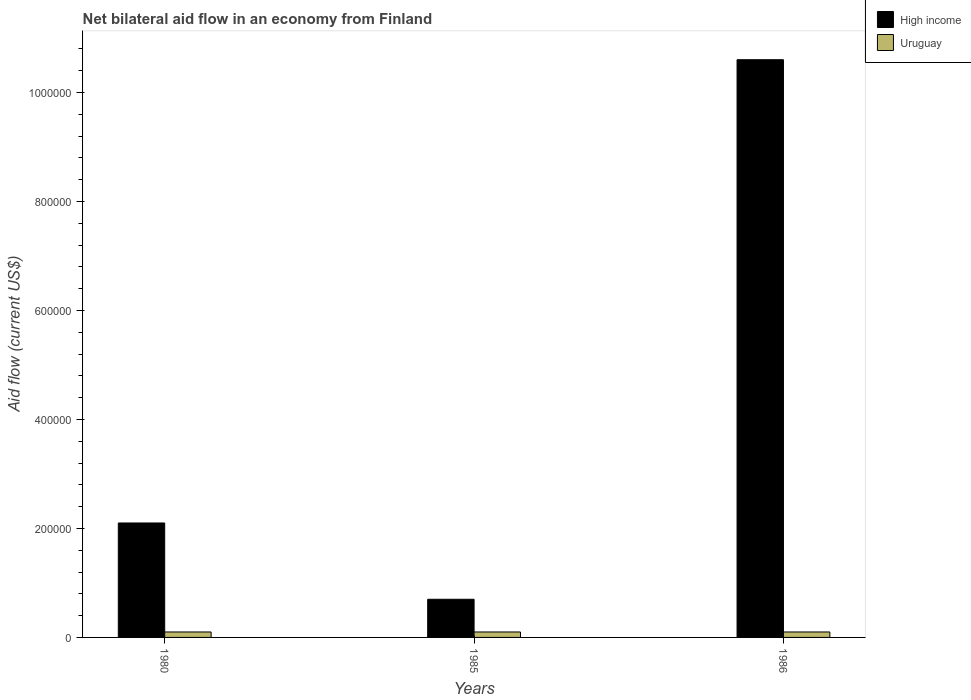How many different coloured bars are there?
Provide a succinct answer. 2. How many groups of bars are there?
Provide a succinct answer. 3. Are the number of bars per tick equal to the number of legend labels?
Make the answer very short. Yes. How many bars are there on the 3rd tick from the right?
Give a very brief answer. 2. What is the label of the 2nd group of bars from the left?
Your answer should be very brief. 1985. In how many cases, is the number of bars for a given year not equal to the number of legend labels?
Your answer should be compact. 0. Across all years, what is the maximum net bilateral aid flow in High income?
Make the answer very short. 1.06e+06. In which year was the net bilateral aid flow in High income maximum?
Give a very brief answer. 1986. In which year was the net bilateral aid flow in Uruguay minimum?
Your answer should be compact. 1980. What is the difference between the net bilateral aid flow in High income in 1980 and that in 1986?
Offer a very short reply. -8.50e+05. What is the difference between the net bilateral aid flow in High income in 1985 and the net bilateral aid flow in Uruguay in 1980?
Ensure brevity in your answer.  6.00e+04. What is the average net bilateral aid flow in High income per year?
Keep it short and to the point. 4.47e+05. In the year 1980, what is the difference between the net bilateral aid flow in Uruguay and net bilateral aid flow in High income?
Make the answer very short. -2.00e+05. Is the net bilateral aid flow in High income in 1980 less than that in 1985?
Your response must be concise. No. Is the difference between the net bilateral aid flow in Uruguay in 1985 and 1986 greater than the difference between the net bilateral aid flow in High income in 1985 and 1986?
Give a very brief answer. Yes. What is the difference between the highest and the second highest net bilateral aid flow in Uruguay?
Offer a terse response. 0. What is the difference between the highest and the lowest net bilateral aid flow in High income?
Provide a short and direct response. 9.90e+05. In how many years, is the net bilateral aid flow in High income greater than the average net bilateral aid flow in High income taken over all years?
Your response must be concise. 1. Is the sum of the net bilateral aid flow in Uruguay in 1980 and 1985 greater than the maximum net bilateral aid flow in High income across all years?
Your answer should be compact. No. What does the 2nd bar from the left in 1986 represents?
Keep it short and to the point. Uruguay. What does the 1st bar from the right in 1986 represents?
Keep it short and to the point. Uruguay. Are all the bars in the graph horizontal?
Give a very brief answer. No. Are the values on the major ticks of Y-axis written in scientific E-notation?
Your answer should be very brief. No. How many legend labels are there?
Offer a terse response. 2. How are the legend labels stacked?
Make the answer very short. Vertical. What is the title of the graph?
Make the answer very short. Net bilateral aid flow in an economy from Finland. What is the label or title of the Y-axis?
Keep it short and to the point. Aid flow (current US$). What is the Aid flow (current US$) of High income in 1980?
Make the answer very short. 2.10e+05. What is the Aid flow (current US$) of High income in 1985?
Your response must be concise. 7.00e+04. What is the Aid flow (current US$) in High income in 1986?
Offer a very short reply. 1.06e+06. What is the Aid flow (current US$) in Uruguay in 1986?
Offer a very short reply. 10000. Across all years, what is the maximum Aid flow (current US$) of High income?
Offer a very short reply. 1.06e+06. Across all years, what is the maximum Aid flow (current US$) of Uruguay?
Provide a succinct answer. 10000. Across all years, what is the minimum Aid flow (current US$) of High income?
Your response must be concise. 7.00e+04. Across all years, what is the minimum Aid flow (current US$) of Uruguay?
Offer a terse response. 10000. What is the total Aid flow (current US$) of High income in the graph?
Give a very brief answer. 1.34e+06. What is the total Aid flow (current US$) of Uruguay in the graph?
Give a very brief answer. 3.00e+04. What is the difference between the Aid flow (current US$) in High income in 1980 and that in 1985?
Make the answer very short. 1.40e+05. What is the difference between the Aid flow (current US$) of Uruguay in 1980 and that in 1985?
Make the answer very short. 0. What is the difference between the Aid flow (current US$) of High income in 1980 and that in 1986?
Offer a terse response. -8.50e+05. What is the difference between the Aid flow (current US$) in High income in 1985 and that in 1986?
Give a very brief answer. -9.90e+05. What is the difference between the Aid flow (current US$) in High income in 1980 and the Aid flow (current US$) in Uruguay in 1986?
Your answer should be very brief. 2.00e+05. What is the average Aid flow (current US$) in High income per year?
Your answer should be compact. 4.47e+05. What is the average Aid flow (current US$) in Uruguay per year?
Your answer should be very brief. 10000. In the year 1980, what is the difference between the Aid flow (current US$) of High income and Aid flow (current US$) of Uruguay?
Ensure brevity in your answer.  2.00e+05. In the year 1986, what is the difference between the Aid flow (current US$) in High income and Aid flow (current US$) in Uruguay?
Your answer should be very brief. 1.05e+06. What is the ratio of the Aid flow (current US$) of Uruguay in 1980 to that in 1985?
Keep it short and to the point. 1. What is the ratio of the Aid flow (current US$) in High income in 1980 to that in 1986?
Offer a very short reply. 0.2. What is the ratio of the Aid flow (current US$) in Uruguay in 1980 to that in 1986?
Ensure brevity in your answer.  1. What is the ratio of the Aid flow (current US$) in High income in 1985 to that in 1986?
Your response must be concise. 0.07. What is the difference between the highest and the second highest Aid flow (current US$) in High income?
Provide a succinct answer. 8.50e+05. What is the difference between the highest and the lowest Aid flow (current US$) in High income?
Your response must be concise. 9.90e+05. 